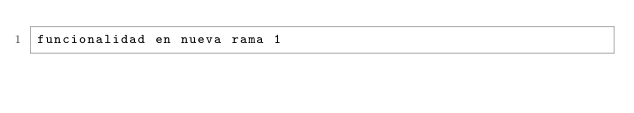Convert code to text. <code><loc_0><loc_0><loc_500><loc_500><_HTML_>funcionalidad en nueva rama 1</code> 